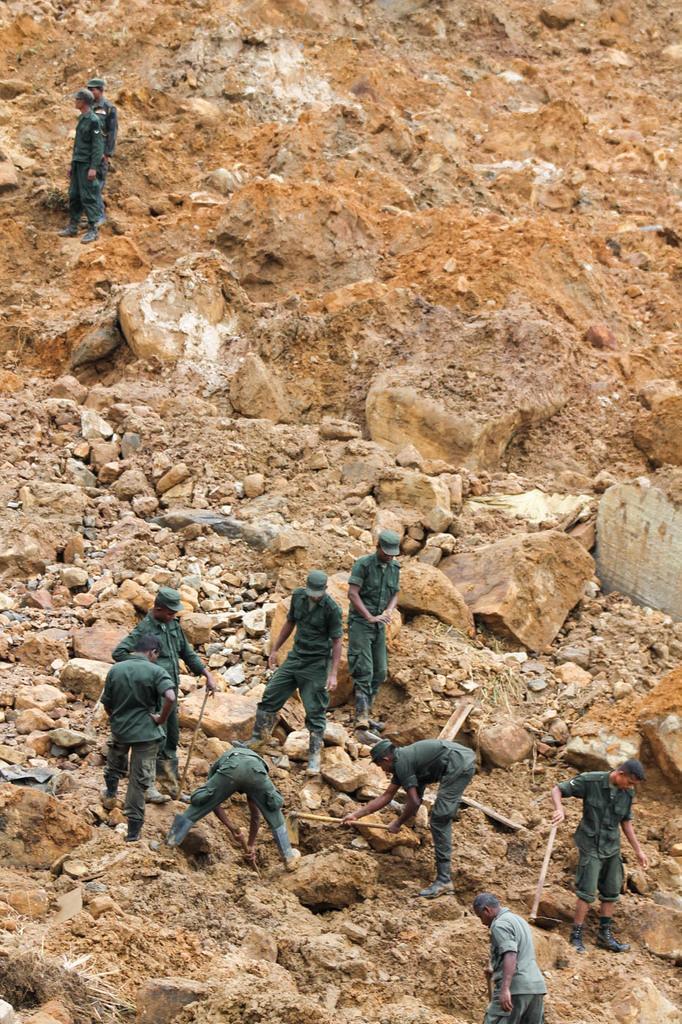Please provide a concise description of this image. In this image we can see men are doing work on the rocky area. They are wearing green color uniform. 